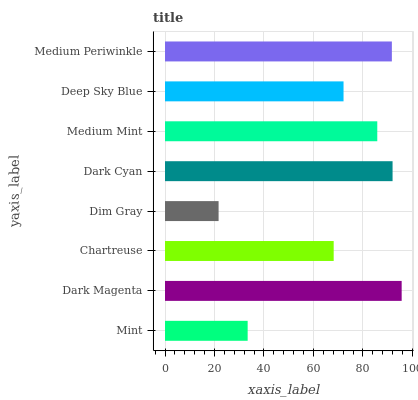Is Dim Gray the minimum?
Answer yes or no. Yes. Is Dark Magenta the maximum?
Answer yes or no. Yes. Is Chartreuse the minimum?
Answer yes or no. No. Is Chartreuse the maximum?
Answer yes or no. No. Is Dark Magenta greater than Chartreuse?
Answer yes or no. Yes. Is Chartreuse less than Dark Magenta?
Answer yes or no. Yes. Is Chartreuse greater than Dark Magenta?
Answer yes or no. No. Is Dark Magenta less than Chartreuse?
Answer yes or no. No. Is Medium Mint the high median?
Answer yes or no. Yes. Is Deep Sky Blue the low median?
Answer yes or no. Yes. Is Dark Cyan the high median?
Answer yes or no. No. Is Chartreuse the low median?
Answer yes or no. No. 